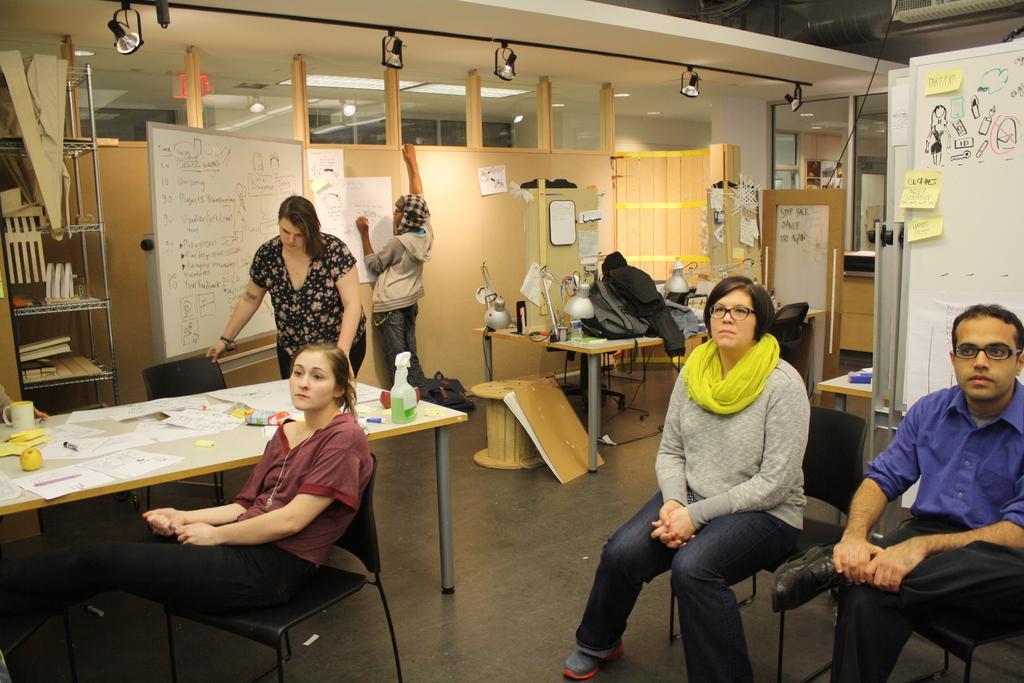How would you summarize this image in a sentence or two? This is an inside view of a room. Here I can see three persons are sitting on the chairs and looking at the left side. Two persons are standing. In the background there are few tables on which papers, lamps and many other objects are placed and also there are many boards on which I can see the papers and text. On the left side there is a rack in which books and some other objects are placed. There are few objects on the floor. In the background there is a glass and also I can see few lights to the ceiling. 